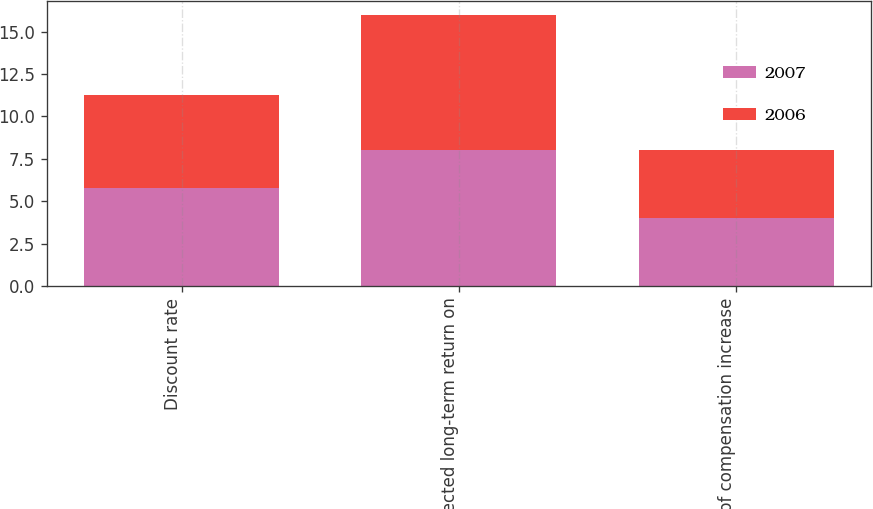Convert chart to OTSL. <chart><loc_0><loc_0><loc_500><loc_500><stacked_bar_chart><ecel><fcel>Discount rate<fcel>Expected long-term return on<fcel>Rate of compensation increase<nl><fcel>2007<fcel>5.75<fcel>8<fcel>4<nl><fcel>2006<fcel>5.5<fcel>8<fcel>4<nl></chart> 